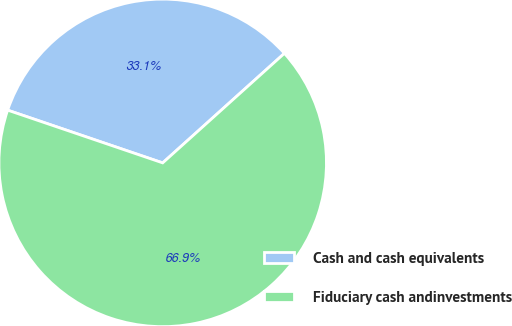Convert chart. <chart><loc_0><loc_0><loc_500><loc_500><pie_chart><fcel>Cash and cash equivalents<fcel>Fiduciary cash andinvestments<nl><fcel>33.12%<fcel>66.88%<nl></chart> 